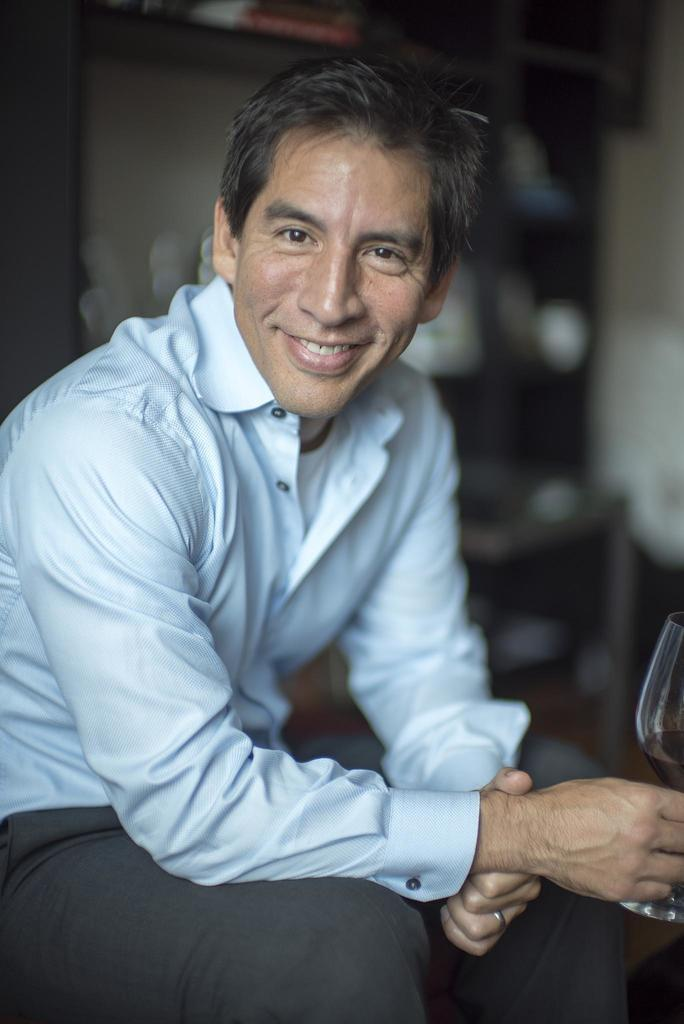Who is present in the image? There is a man in the image. What is the man doing in the image? The man is sitting in the image. What is the man holding in his hand? The man is holding a glass in his hand. What is the man's facial expression in the image? The man is smiling in the image. How many ducks are present in the image? There are no ducks present in the image. Are the man's sisters also in the image? The provided facts do not mention any sisters, so we cannot determine if they are present in the image. 